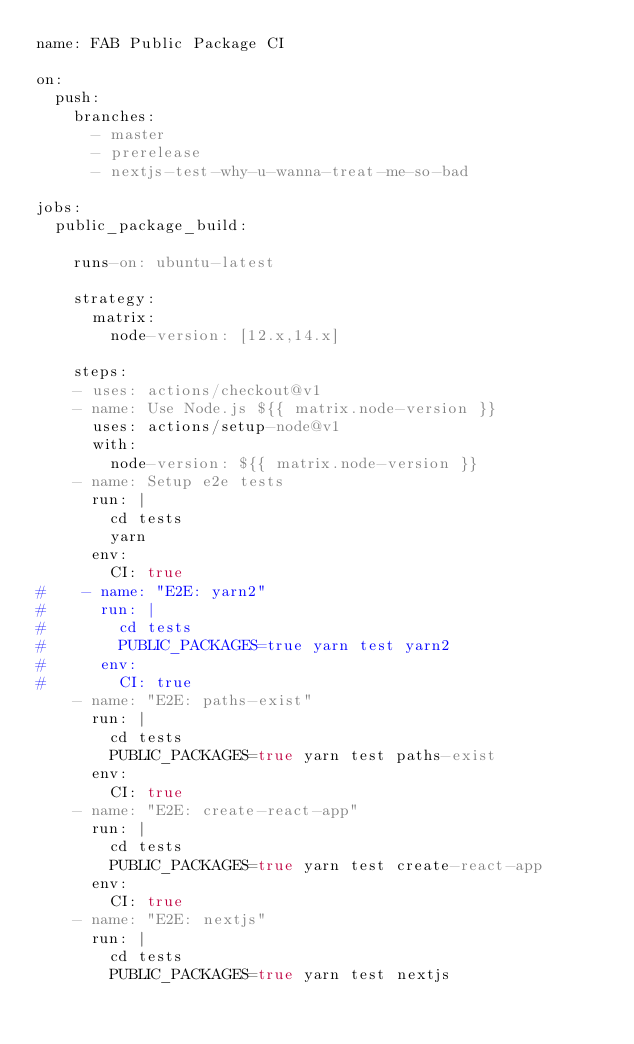<code> <loc_0><loc_0><loc_500><loc_500><_YAML_>name: FAB Public Package CI

on:
  push:
    branches:
      - master
      - prerelease
      - nextjs-test-why-u-wanna-treat-me-so-bad

jobs:
  public_package_build:

    runs-on: ubuntu-latest

    strategy:
      matrix:
        node-version: [12.x,14.x]

    steps:
    - uses: actions/checkout@v1
    - name: Use Node.js ${{ matrix.node-version }}
      uses: actions/setup-node@v1
      with:
        node-version: ${{ matrix.node-version }}
    - name: Setup e2e tests
      run: |
        cd tests
        yarn
      env:
        CI: true
#    - name: "E2E: yarn2"
#      run: |
#        cd tests
#        PUBLIC_PACKAGES=true yarn test yarn2
#      env:
#        CI: true
    - name: "E2E: paths-exist"
      run: |
        cd tests
        PUBLIC_PACKAGES=true yarn test paths-exist
      env:
        CI: true
    - name: "E2E: create-react-app"
      run: |
        cd tests
        PUBLIC_PACKAGES=true yarn test create-react-app
      env:
        CI: true
    - name: "E2E: nextjs"
      run: |
        cd tests
        PUBLIC_PACKAGES=true yarn test nextjs
</code> 